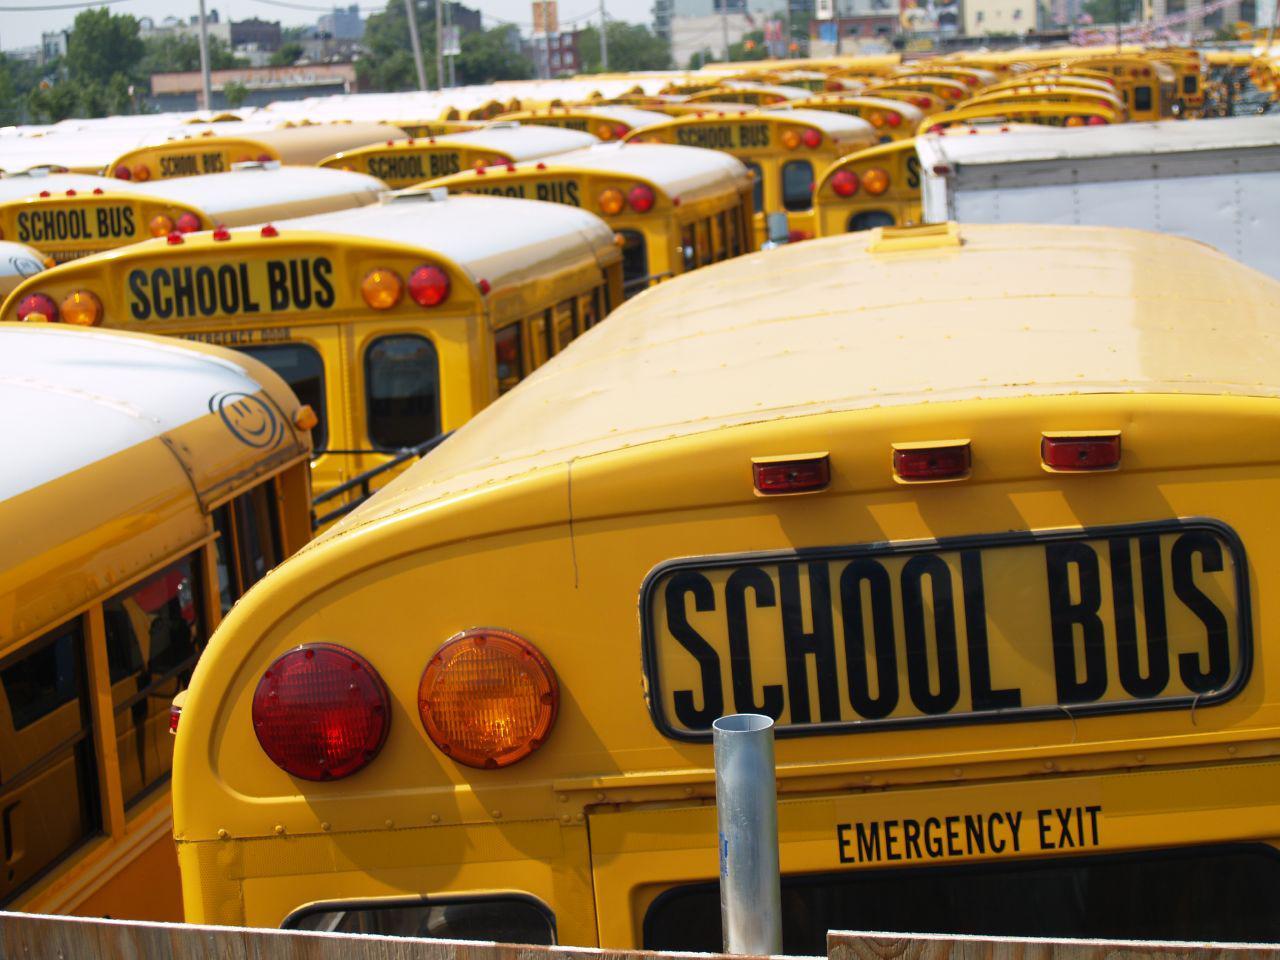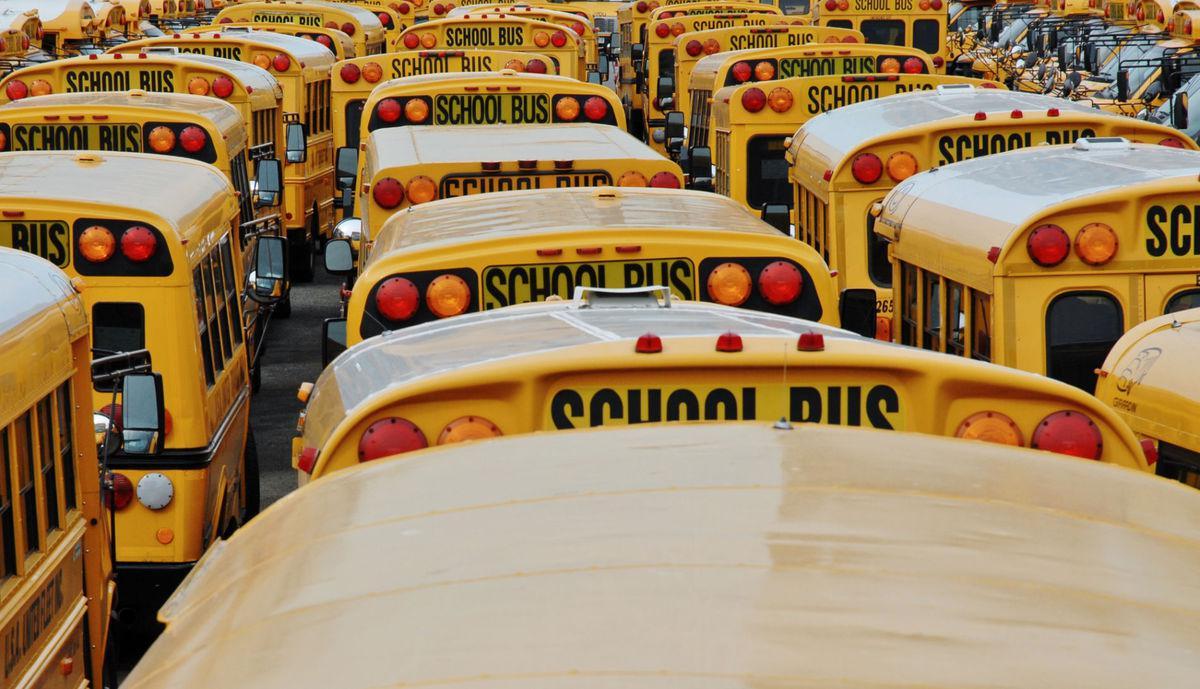The first image is the image on the left, the second image is the image on the right. Given the left and right images, does the statement "One of the busses has graffiti on it." hold true? Answer yes or no. No. The first image is the image on the left, the second image is the image on the right. Given the left and right images, does the statement "The photo on the right shows a school bus that has been painted, while the image on the left shows a row of at least five school buses." hold true? Answer yes or no. No. 